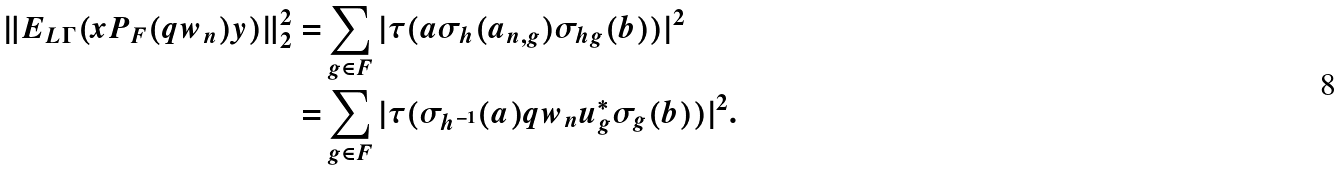Convert formula to latex. <formula><loc_0><loc_0><loc_500><loc_500>\| E _ { L \Gamma } ( x P _ { F } ( q w _ { n } ) y ) \| _ { 2 } ^ { 2 } = & \sum _ { g \in F } | \tau ( a \sigma _ { h } ( a _ { n , g } ) \sigma _ { h g } ( b ) ) | ^ { 2 } \\ = & \sum _ { g \in F } | \tau ( \sigma _ { h ^ { - 1 } } ( a ) q w _ { n } u _ { g } ^ { * } \sigma _ { g } ( b ) ) | ^ { 2 } .</formula> 